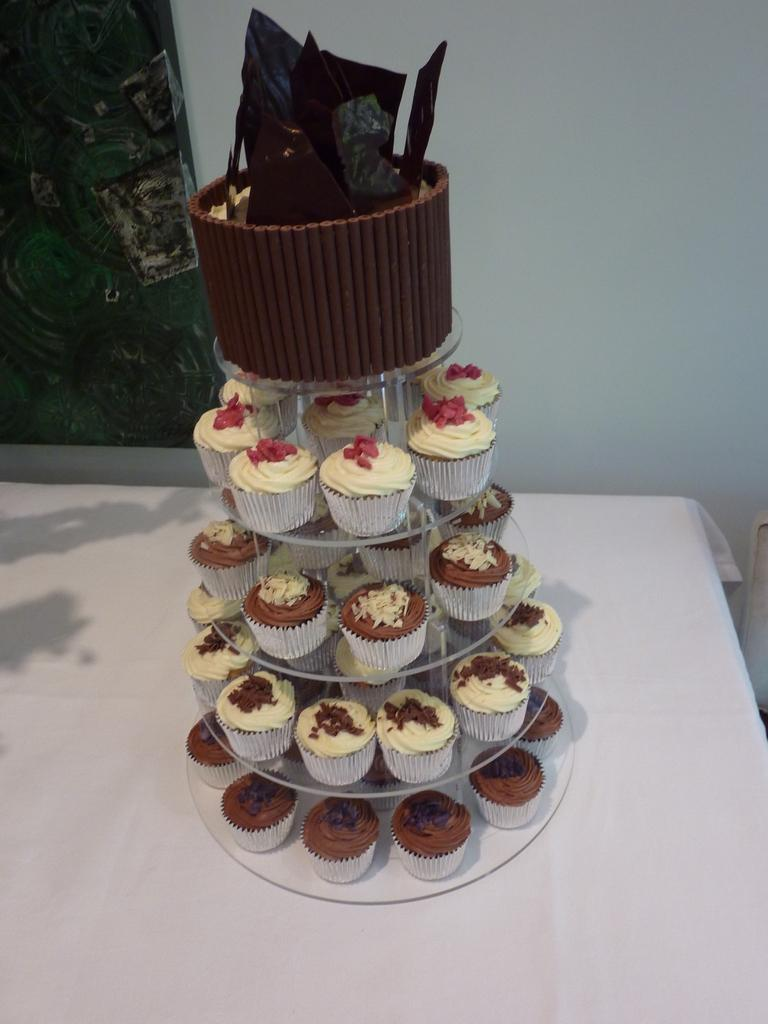What type of dessert is featured in the image? There are cupcakes in the image. How are the cupcakes arranged or displayed? The cupcakes are in a cake stand. Where is the cake stand located? The cake stand is placed on a table. What type of print is visible on the cupcakes in the image? There is no print visible on the cupcakes in the image. Is there a birthday celebration happening in the image? The image does not provide any information about a birthday celebration. 